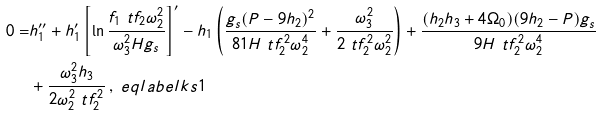<formula> <loc_0><loc_0><loc_500><loc_500>0 = & h _ { 1 } ^ { \prime \prime } + h _ { 1 } ^ { \prime } \left [ \ln \frac { f _ { 1 } \ t f _ { 2 } \omega _ { 2 } ^ { 2 } } { \omega _ { 3 } ^ { 2 } H g _ { s } } \right ] ^ { \prime } - h _ { 1 } \left ( \frac { g _ { s } ( P - 9 h _ { 2 } ) ^ { 2 } } { 8 1 H \ t f _ { 2 } ^ { 2 } \omega _ { 2 } ^ { 4 } } + \frac { \omega _ { 3 } ^ { 2 } } { 2 \ t f _ { 2 } ^ { 2 } \omega _ { 2 } ^ { 2 } } \right ) + \frac { ( h _ { 2 } h _ { 3 } + 4 \Omega _ { 0 } ) ( 9 h _ { 2 } - P ) g _ { s } } { 9 H \ t f _ { 2 } ^ { 2 } \omega _ { 2 } ^ { 4 } } \\ & + \frac { \omega _ { 3 } ^ { 2 } h _ { 3 } } { 2 \omega _ { 2 } ^ { 2 } \ t f _ { 2 } ^ { 2 } } \, , \ e q l a b e l { k s 1 }</formula> 